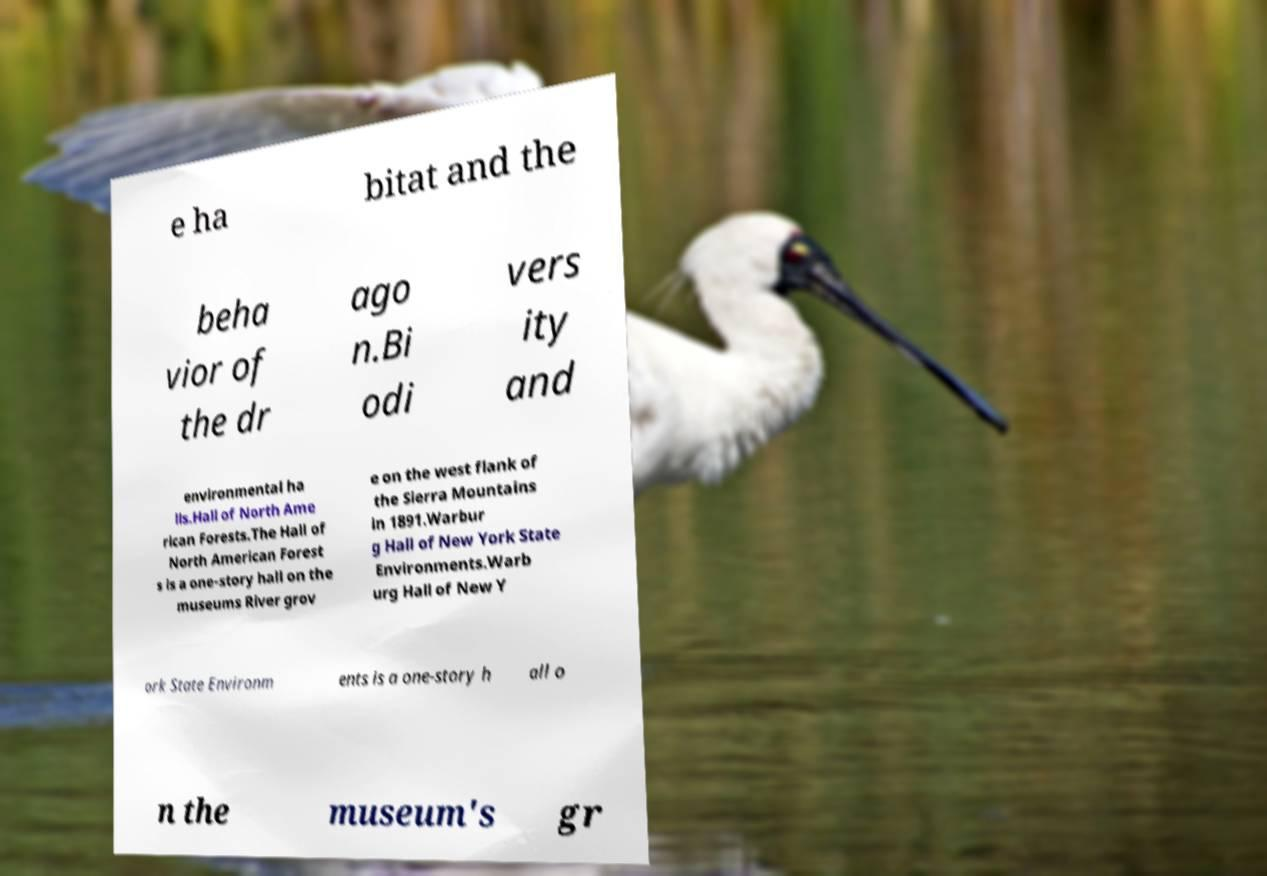Could you assist in decoding the text presented in this image and type it out clearly? e ha bitat and the beha vior of the dr ago n.Bi odi vers ity and environmental ha lls.Hall of North Ame rican Forests.The Hall of North American Forest s is a one-story hall on the museums River grov e on the west flank of the Sierra Mountains in 1891.Warbur g Hall of New York State Environments.Warb urg Hall of New Y ork State Environm ents is a one-story h all o n the museum's gr 